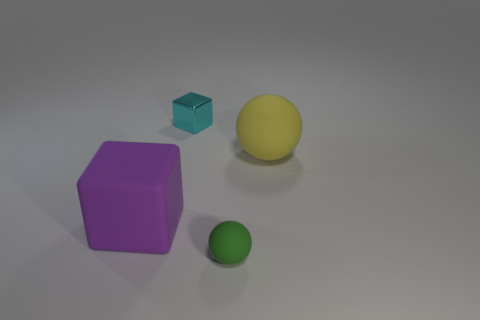What number of cylinders are either tiny blue shiny things or cyan shiny things?
Give a very brief answer. 0. What is the size of the metallic cube?
Offer a very short reply. Small. There is a cyan shiny thing; how many large yellow things are in front of it?
Provide a short and direct response. 1. What is the size of the ball that is to the left of the large rubber object to the right of the tiny block?
Offer a terse response. Small. Does the small thing behind the green rubber object have the same shape as the big thing that is to the left of the yellow ball?
Your answer should be compact. Yes. What shape is the tiny cyan object that is right of the matte thing that is on the left side of the tiny cyan metal cube?
Your response must be concise. Cube. There is a thing that is both on the left side of the tiny green rubber sphere and behind the big cube; how big is it?
Your answer should be very brief. Small. Does the purple thing have the same shape as the small thing in front of the small block?
Provide a short and direct response. No. There is a yellow thing that is the same shape as the tiny green thing; what is its size?
Offer a very short reply. Large. What number of other things are the same size as the yellow rubber sphere?
Offer a terse response. 1. 